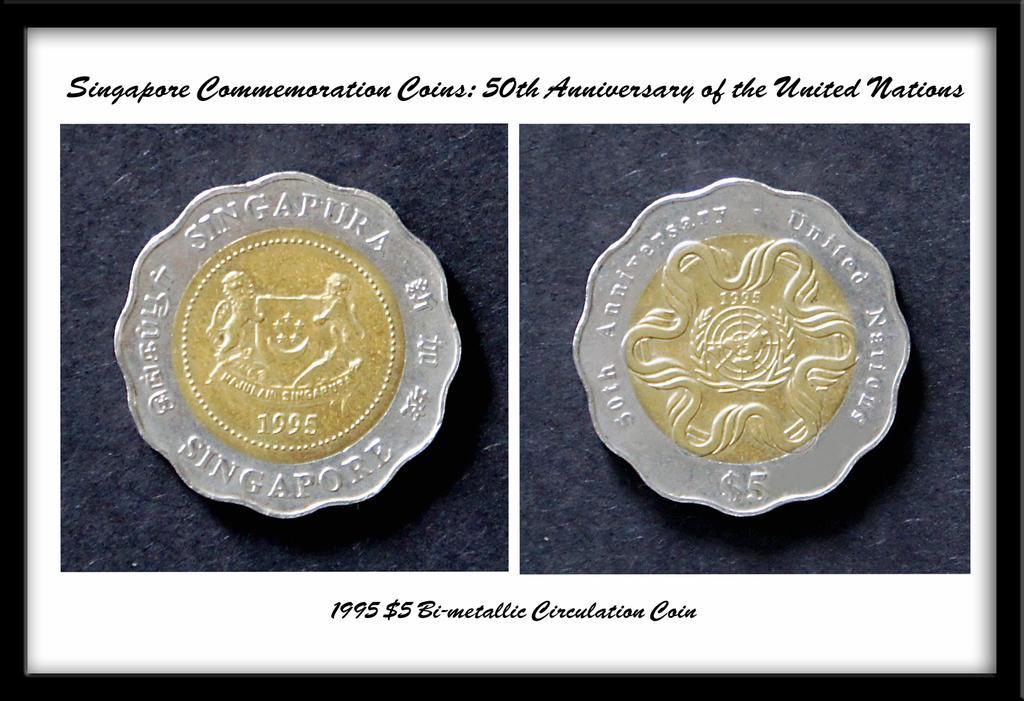Please provide a concise description of this image. In this picture I can see couple of images of coins and I can see text at the top and at the bottom of the picture. It looks like a photo frame. 